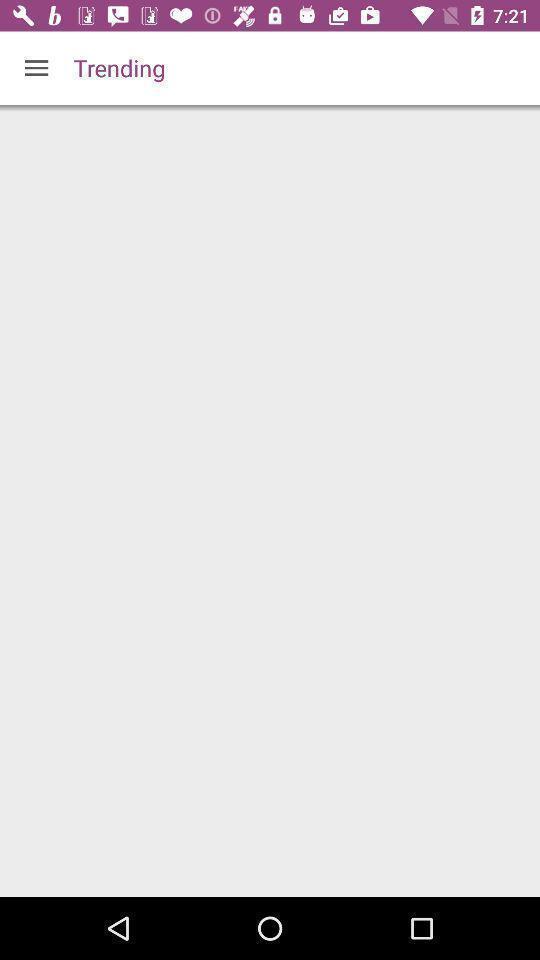Give me a summary of this screen capture. Trending page of the app. 